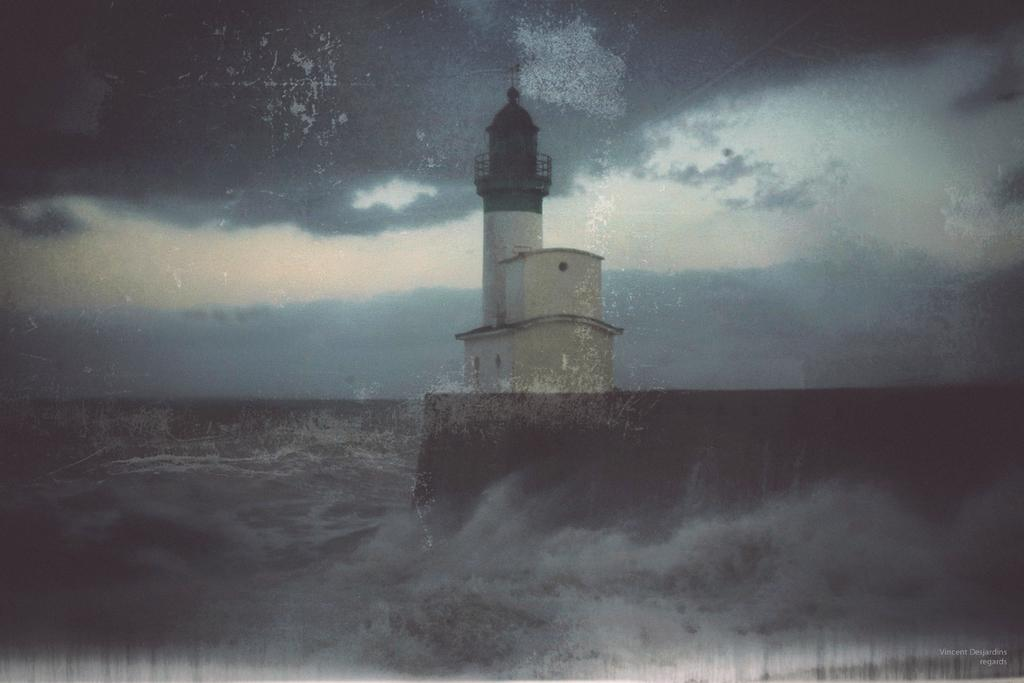How has the image been altered? The image is edited. What can be seen at the bottom of the image? There is water at the bottom of the image, which appears to be an ocean. What is located in the middle of the image? There is a tower in the middle of the image. What is visible at the top of the image? The sky is visible at the top of the image. What can be seen in the sky? Clouds are present in the sky. What type of neck is visible on the tower in the image? There is no neck present on the tower in the image; it is a solid structure. 